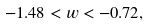Convert formula to latex. <formula><loc_0><loc_0><loc_500><loc_500>- 1 . 4 8 < w < - 0 . 7 2 ,</formula> 